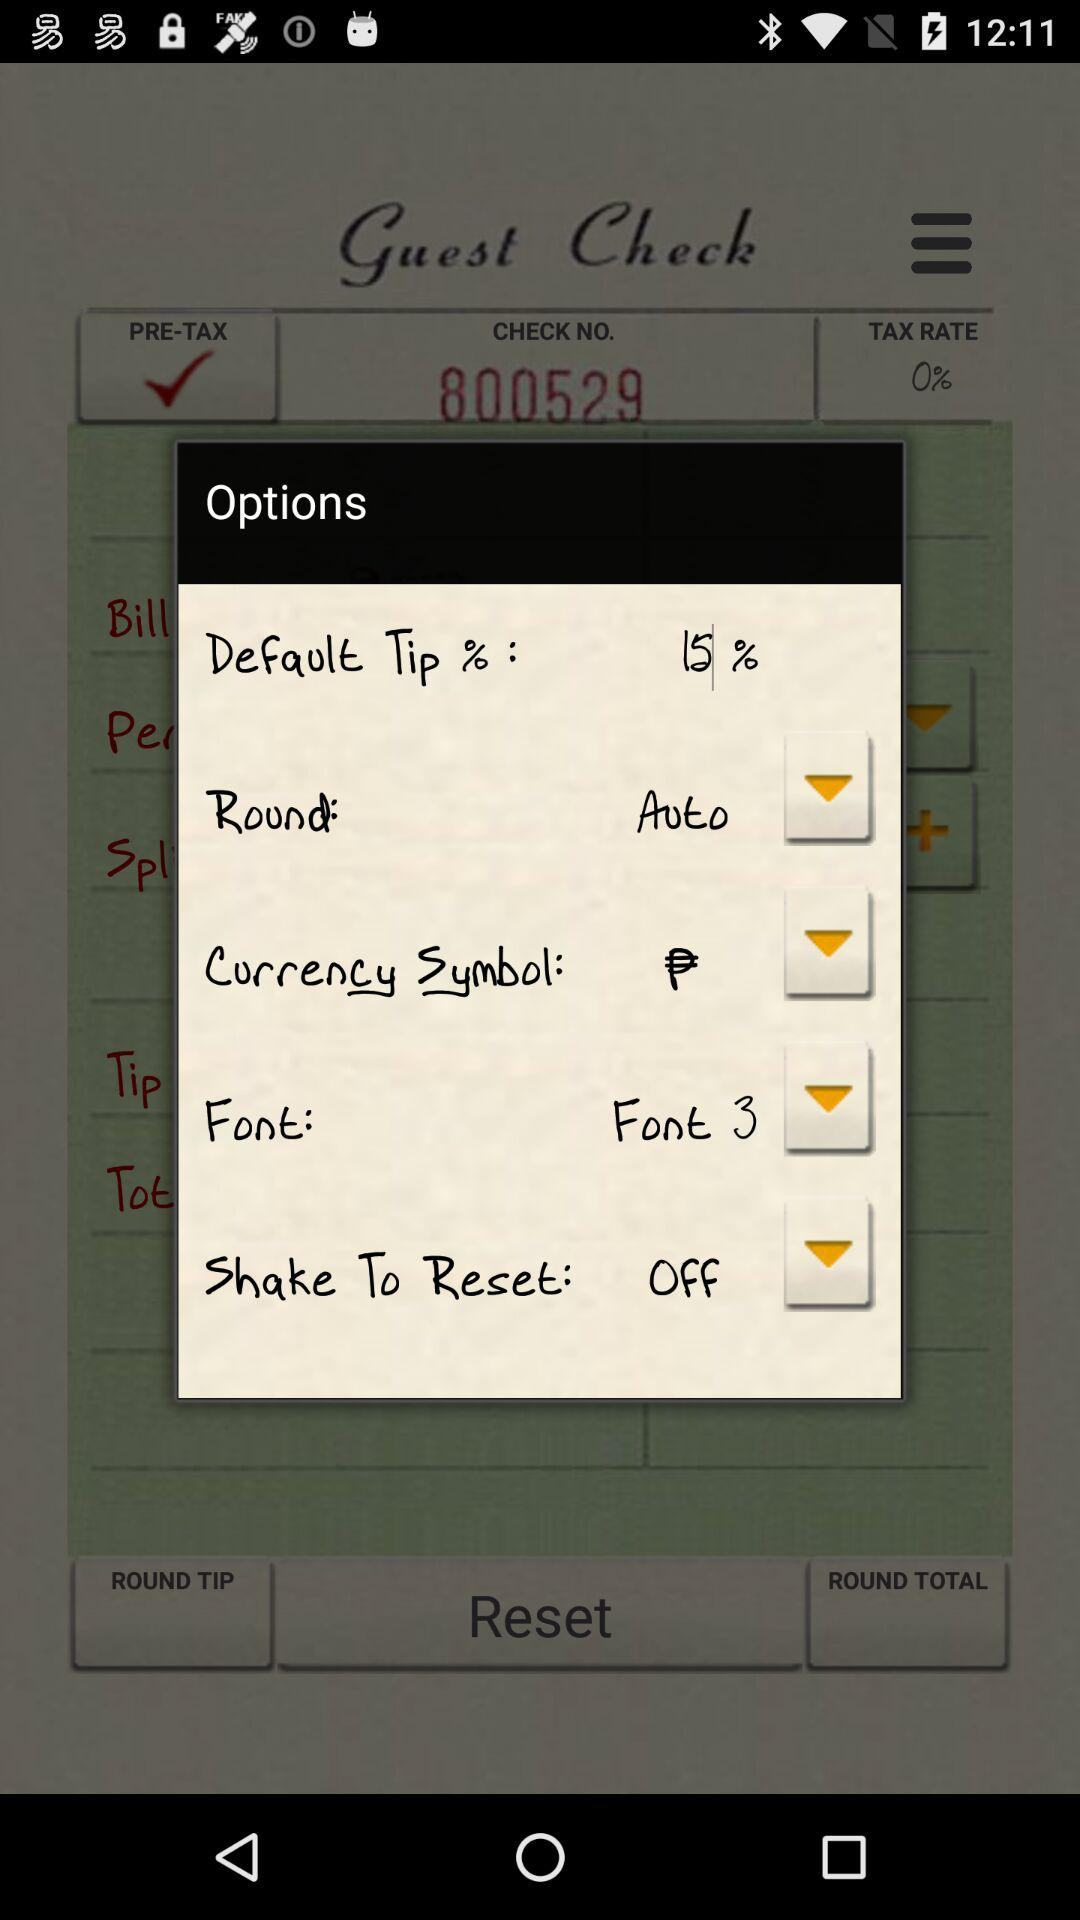Which setting is selected for "Round" option? The selected setting is "Auto". 